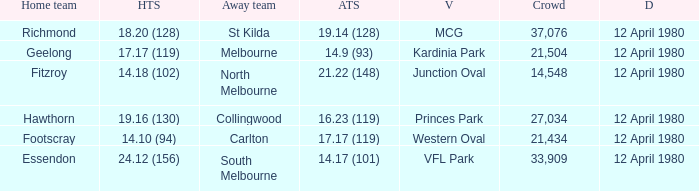Who was North Melbourne's home opponent? Fitzroy. 